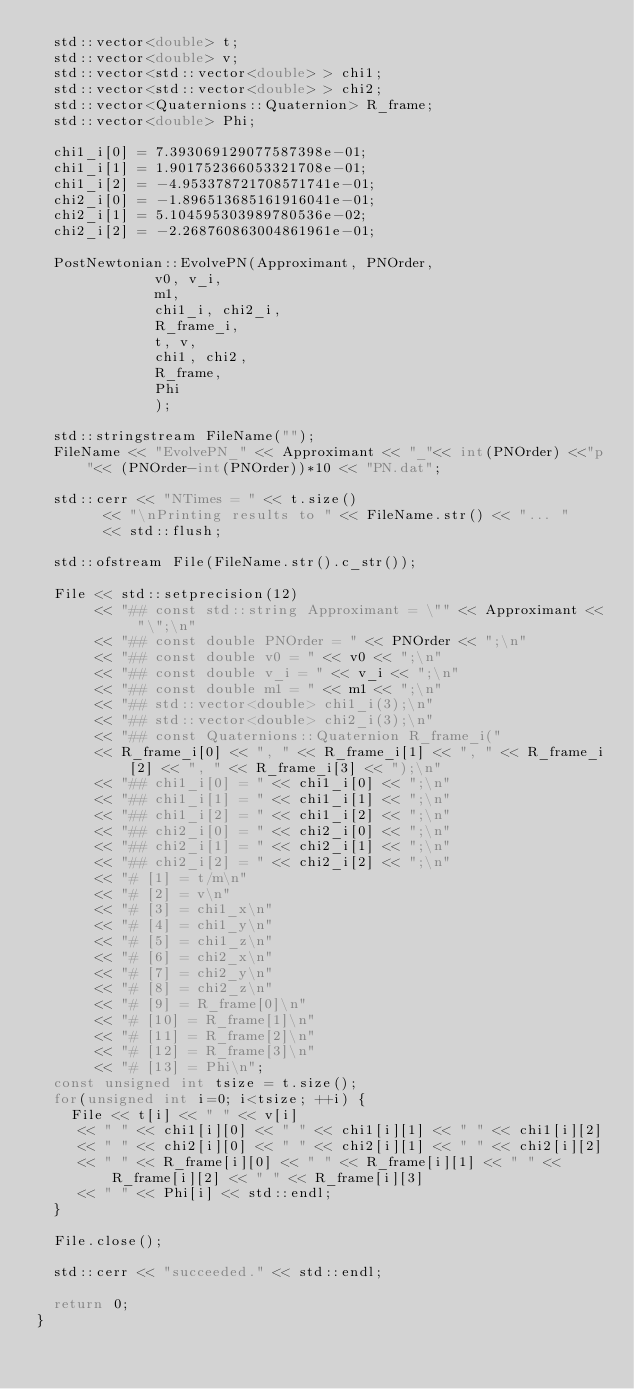<code> <loc_0><loc_0><loc_500><loc_500><_C++_>  std::vector<double> t;
  std::vector<double> v;
  std::vector<std::vector<double> > chi1;
  std::vector<std::vector<double> > chi2;
  std::vector<Quaternions::Quaternion> R_frame;
  std::vector<double> Phi;

  chi1_i[0] = 7.393069129077587398e-01;
  chi1_i[1] = 1.901752366053321708e-01;
  chi1_i[2] = -4.953378721708571741e-01;
  chi2_i[0] = -1.896513685161916041e-01;
  chi2_i[1] = 5.104595303989780536e-02;
  chi2_i[2] = -2.268760863004861961e-01;

  PostNewtonian::EvolvePN(Approximant, PNOrder,
			  v0, v_i,
			  m1,
			  chi1_i, chi2_i,
			  R_frame_i,
			  t, v,
			  chi1, chi2,
			  R_frame,
			  Phi
			  );

  std::stringstream FileName("");
  FileName << "EvolvePN_" << Approximant << "_"<< int(PNOrder) <<"p"<< (PNOrder-int(PNOrder))*10 << "PN.dat";

  std::cerr << "NTimes = " << t.size()
	    << "\nPrinting results to " << FileName.str() << "... "
	    << std::flush;

  std::ofstream File(FileName.str().c_str());

  File << std::setprecision(12)
       << "## const std::string Approximant = \"" << Approximant << "\";\n"
       << "## const double PNOrder = " << PNOrder << ";\n"
       << "## const double v0 = " << v0 << ";\n"
       << "## const double v_i = " << v_i << ";\n"
       << "## const double m1 = " << m1 << ";\n"
       << "## std::vector<double> chi1_i(3);\n"
       << "## std::vector<double> chi2_i(3);\n"
       << "## const Quaternions::Quaternion R_frame_i("
       << R_frame_i[0] << ", " << R_frame_i[1] << ", " << R_frame_i[2] << ", " << R_frame_i[3] << ");\n"
       << "## chi1_i[0] = " << chi1_i[0] << ";\n"
       << "## chi1_i[1] = " << chi1_i[1] << ";\n"
       << "## chi1_i[2] = " << chi1_i[2] << ";\n"
       << "## chi2_i[0] = " << chi2_i[0] << ";\n"
       << "## chi2_i[1] = " << chi2_i[1] << ";\n"
       << "## chi2_i[2] = " << chi2_i[2] << ";\n"
       << "# [1] = t/m\n"
       << "# [2] = v\n"
       << "# [3] = chi1_x\n"
       << "# [4] = chi1_y\n"
       << "# [5] = chi1_z\n"
       << "# [6] = chi2_x\n"
       << "# [7] = chi2_y\n"
       << "# [8] = chi2_z\n"
       << "# [9] = R_frame[0]\n"
       << "# [10] = R_frame[1]\n"
       << "# [11] = R_frame[2]\n"
       << "# [12] = R_frame[3]\n"
       << "# [13] = Phi\n";
  const unsigned int tsize = t.size();
  for(unsigned int i=0; i<tsize; ++i) {
    File << t[i] << " " << v[i]
	 << " " << chi1[i][0] << " " << chi1[i][1] << " " << chi1[i][2]
	 << " " << chi2[i][0] << " " << chi2[i][1] << " " << chi2[i][2]
	 << " " << R_frame[i][0] << " " << R_frame[i][1] << " " << R_frame[i][2] << " " << R_frame[i][3]
	 << " " << Phi[i] << std::endl;
  }

  File.close();

  std::cerr << "succeeded." << std::endl;

  return 0;
}
</code> 